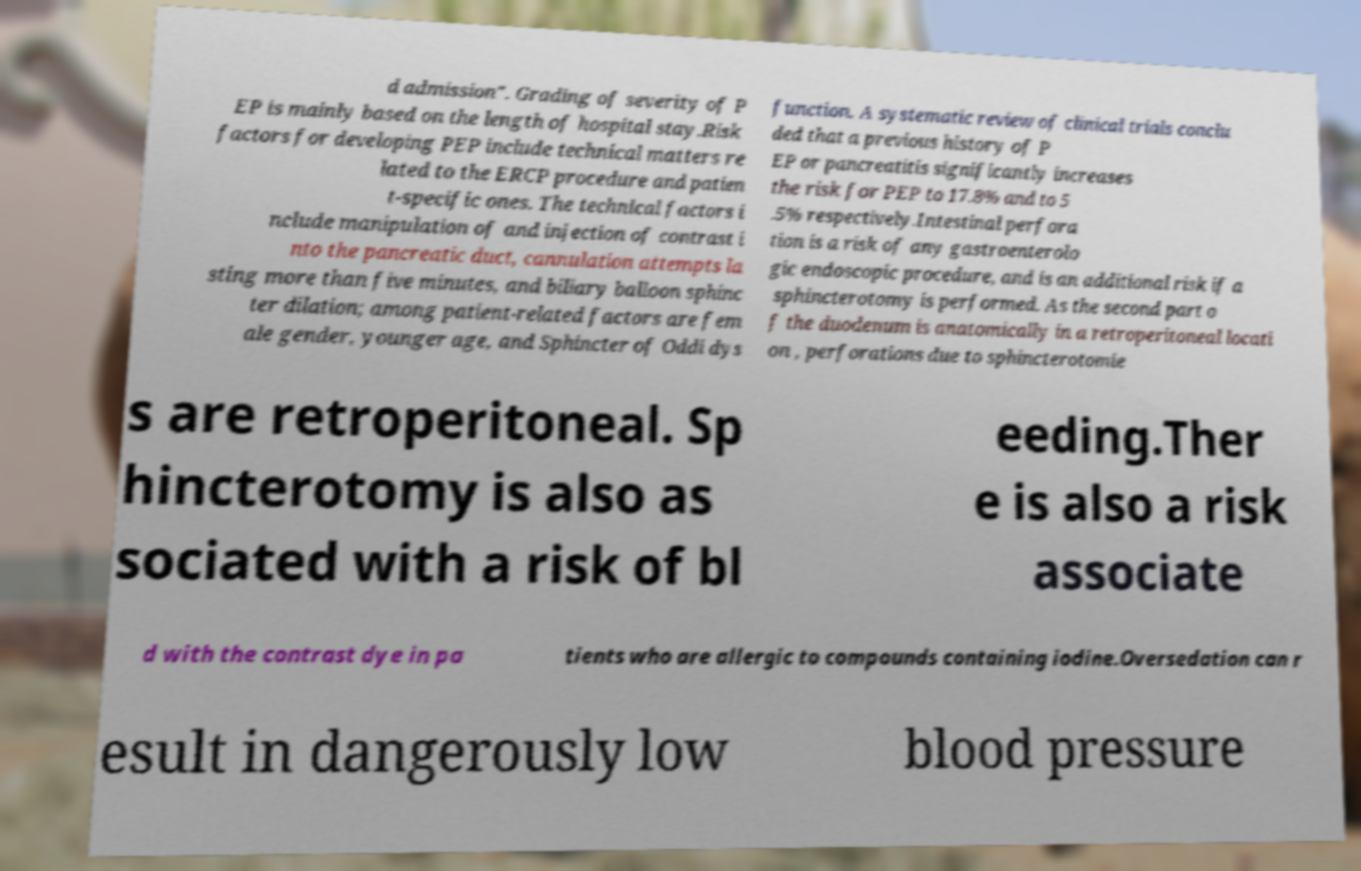Please read and relay the text visible in this image. What does it say? d admission". Grading of severity of P EP is mainly based on the length of hospital stay.Risk factors for developing PEP include technical matters re lated to the ERCP procedure and patien t-specific ones. The technical factors i nclude manipulation of and injection of contrast i nto the pancreatic duct, cannulation attempts la sting more than five minutes, and biliary balloon sphinc ter dilation; among patient-related factors are fem ale gender, younger age, and Sphincter of Oddi dys function. A systematic review of clinical trials conclu ded that a previous history of P EP or pancreatitis significantly increases the risk for PEP to 17.8% and to 5 .5% respectively.Intestinal perfora tion is a risk of any gastroenterolo gic endoscopic procedure, and is an additional risk if a sphincterotomy is performed. As the second part o f the duodenum is anatomically in a retroperitoneal locati on , perforations due to sphincterotomie s are retroperitoneal. Sp hincterotomy is also as sociated with a risk of bl eeding.Ther e is also a risk associate d with the contrast dye in pa tients who are allergic to compounds containing iodine.Oversedation can r esult in dangerously low blood pressure 